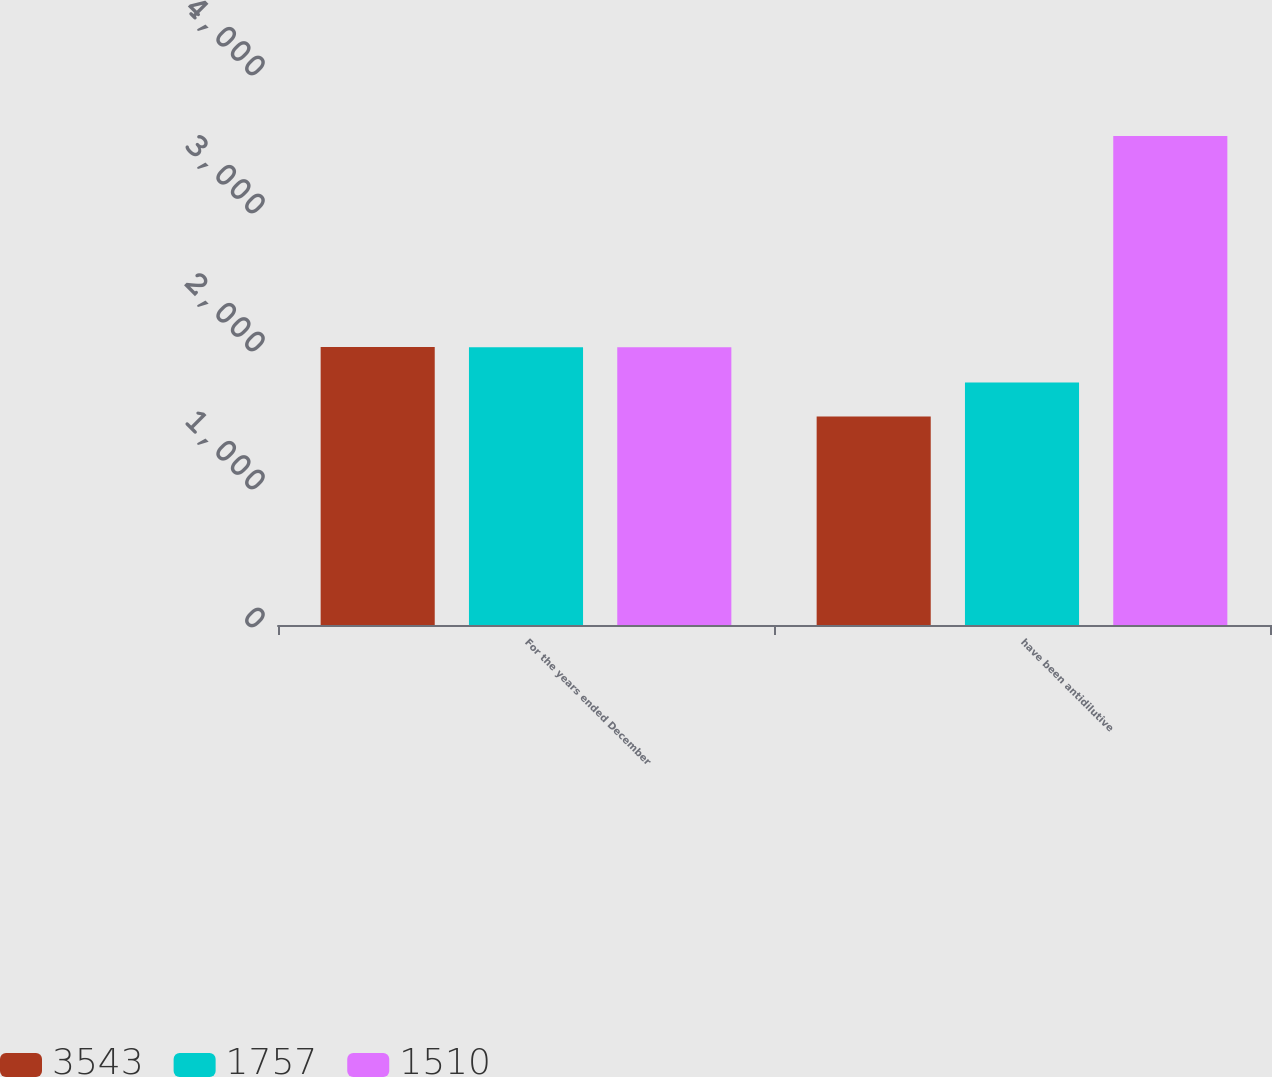Convert chart to OTSL. <chart><loc_0><loc_0><loc_500><loc_500><stacked_bar_chart><ecel><fcel>For the years ended December<fcel>have been antidilutive<nl><fcel>3543<fcel>2014<fcel>1510<nl><fcel>1757<fcel>2013<fcel>1757<nl><fcel>1510<fcel>2012<fcel>3543<nl></chart> 